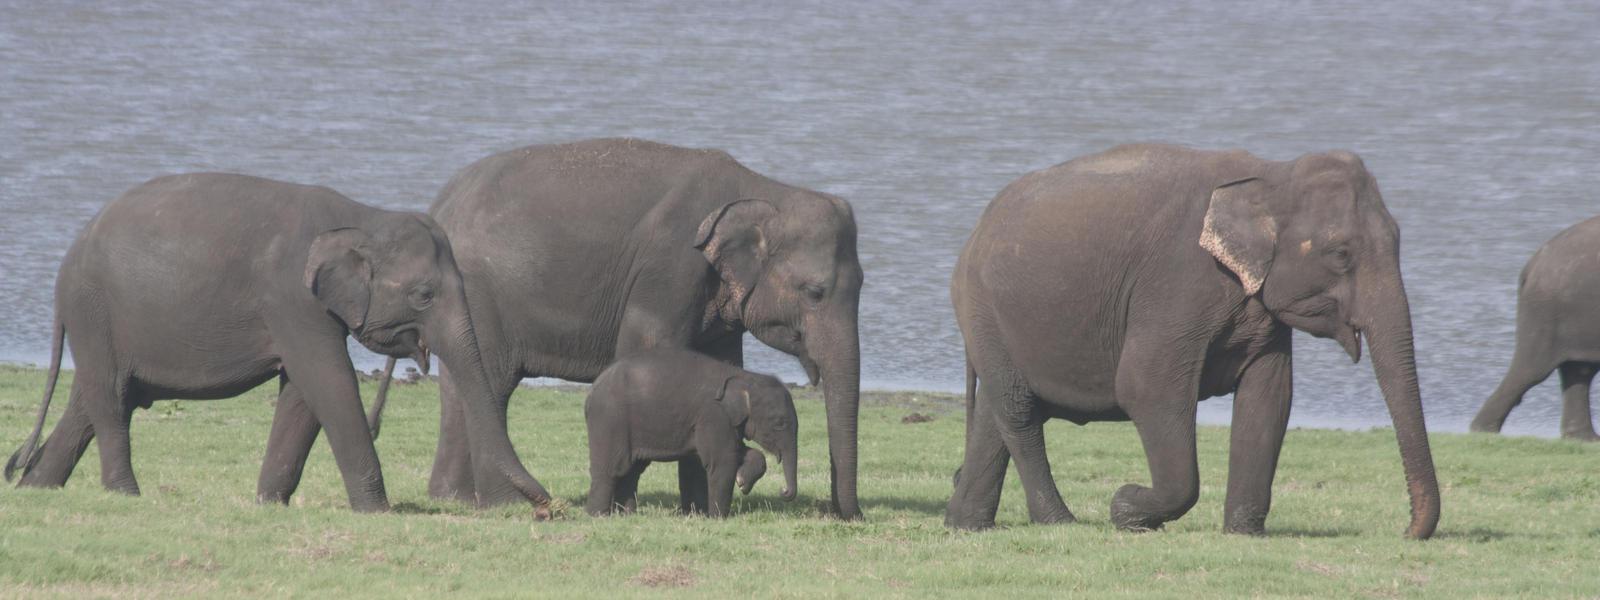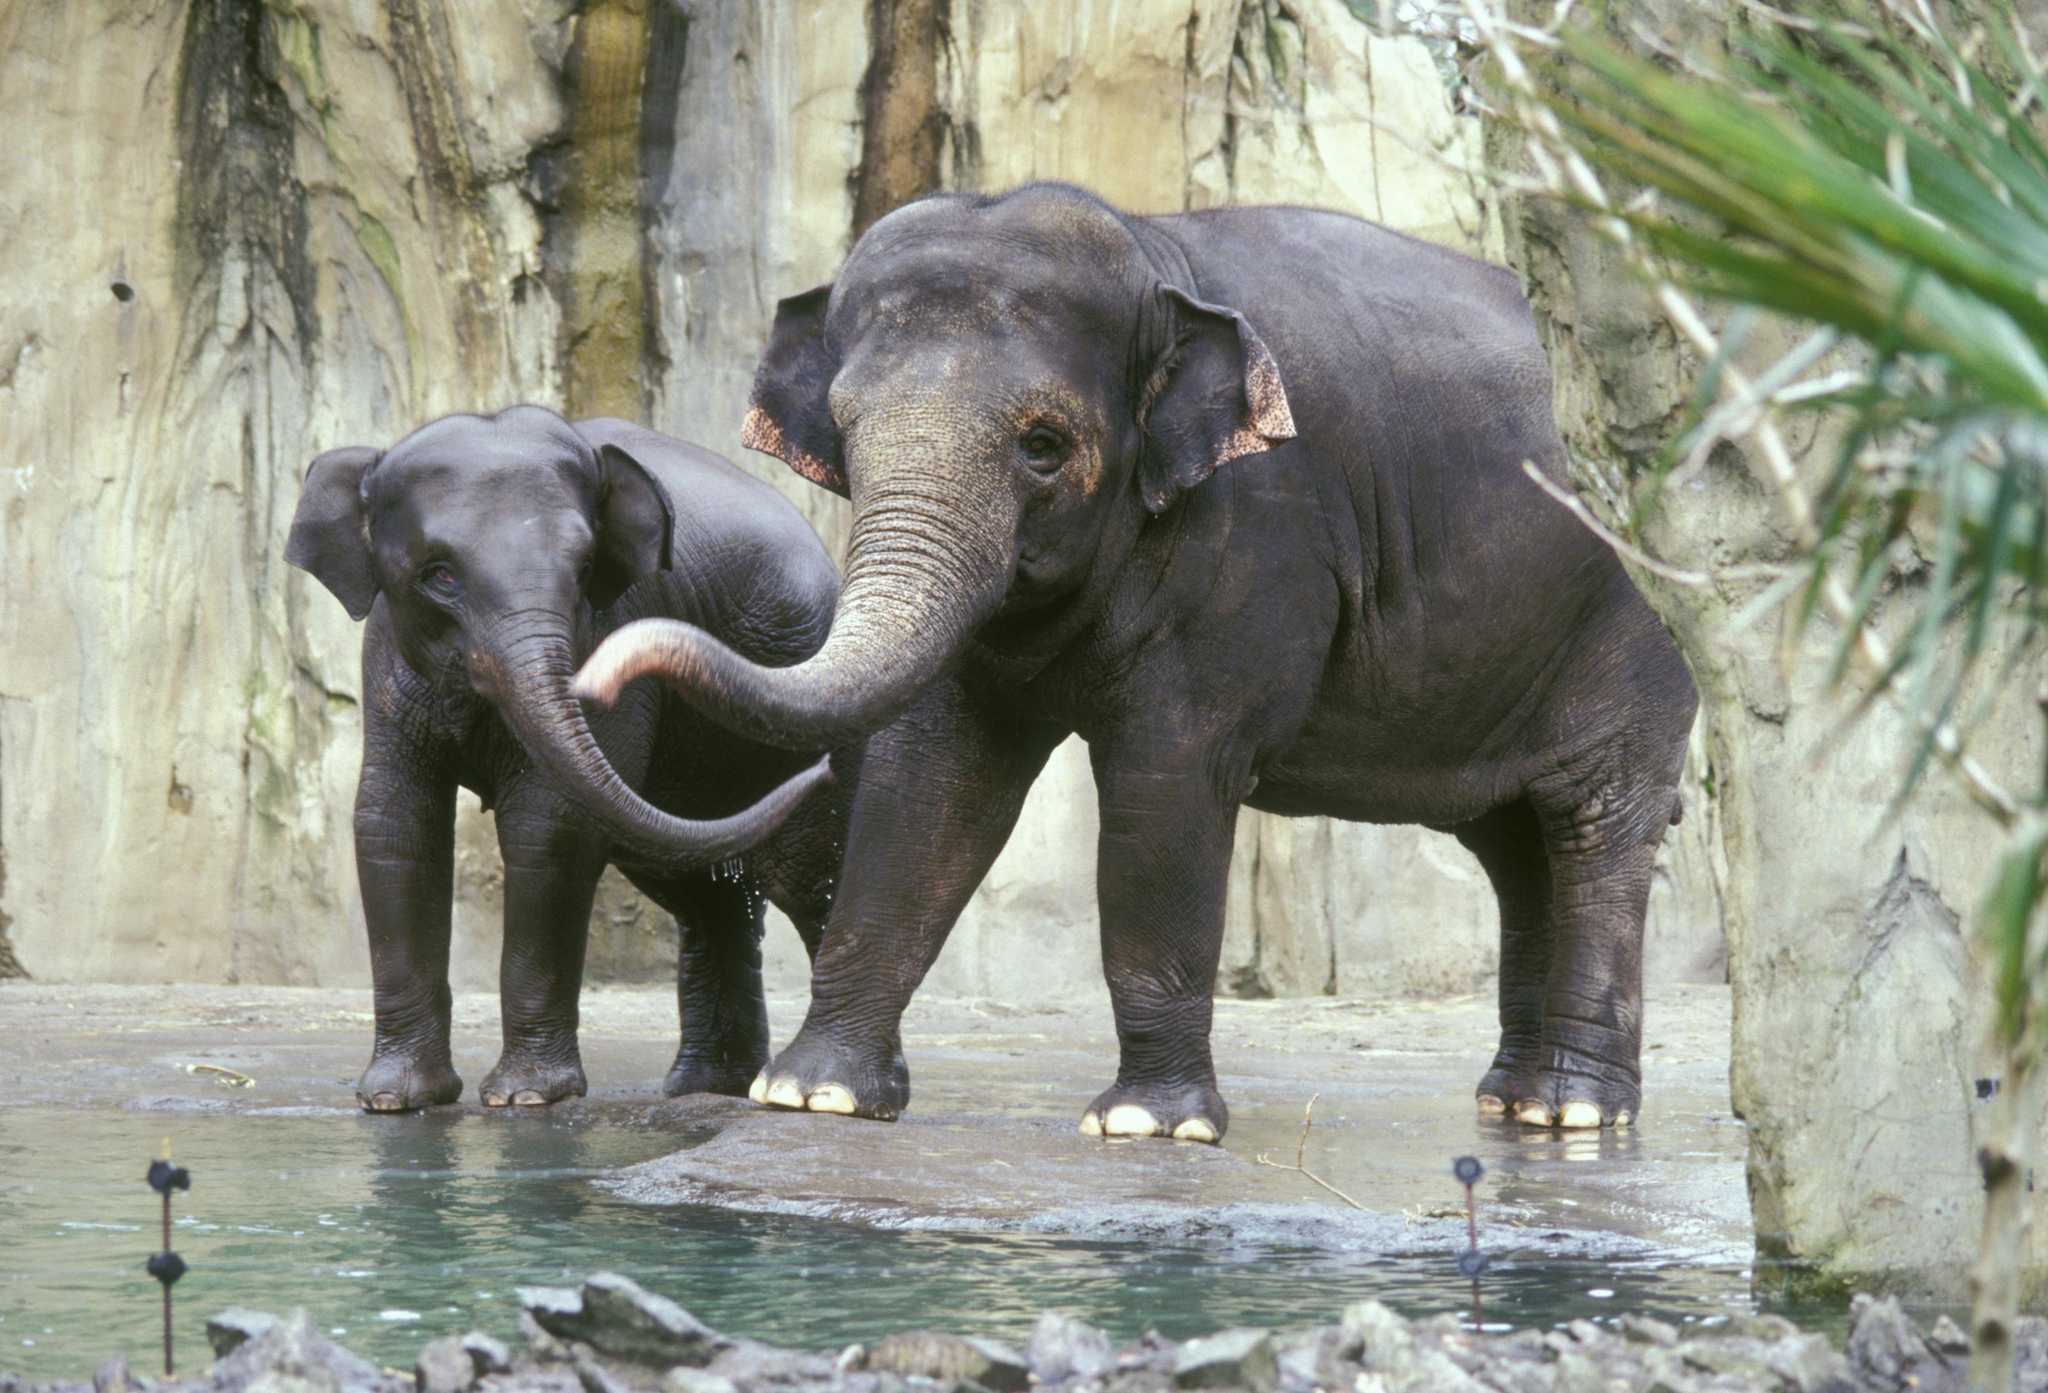The first image is the image on the left, the second image is the image on the right. Assess this claim about the two images: "There are more animals on the left than the right.". Correct or not? Answer yes or no. Yes. 